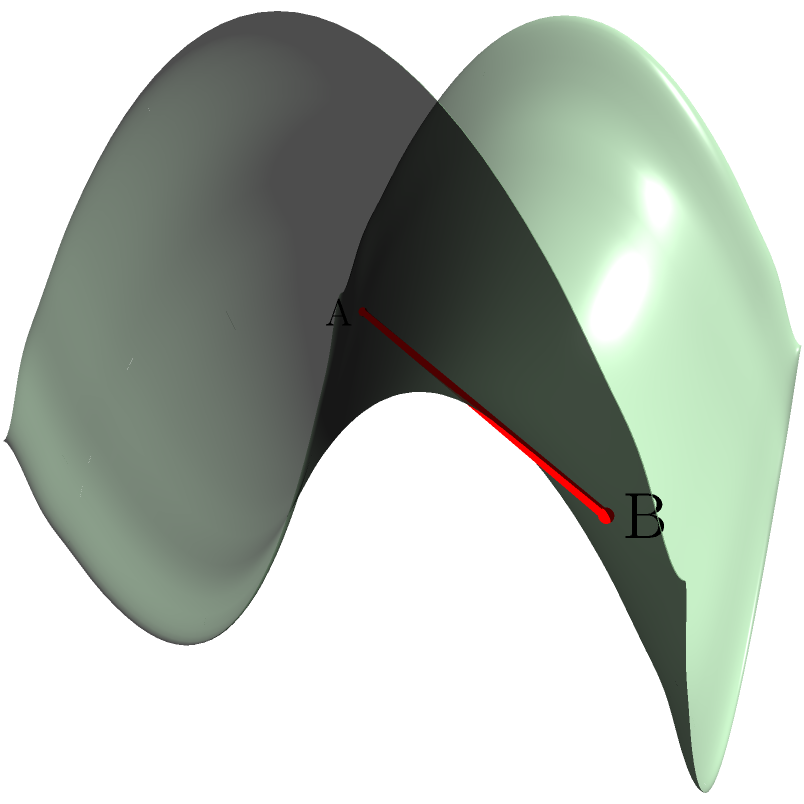On a saddle-shaped surface representing a curved keyboard, points A and B represent two notes that need to be played in rapid succession. Which path would your fingers take to minimize movement between these points? Explain your reasoning using principles of Non-Euclidean Geometry. To understand the shortest path between two points on a saddle-shaped surface, we need to consider the principles of Non-Euclidean Geometry:

1. On a curved surface, the shortest path between two points is called a geodesic.

2. In this case, the surface is a hyperbolic paraboloid, described by the equation $z = 0.5(x^2 - y^2)$.

3. Unlike on a flat surface where the shortest path is a straight line, on a saddle surface, the geodesic can appear curved when viewed from above.

4. The geodesic on this surface follows the principle of minimizing the distance while adhering to the curvature of the surface.

5. In the context of piano playing, this path represents the most efficient movement of fingers across the curved keyboard.

6. The red line in the diagram represents the geodesic between points A and B.

7. Notice that this path is not a straight line when projected onto the xy-plane, but rather follows the curvature of the surface.

8. This curved path allows the fingers to maintain contact with the keyboard surface, minimizing unnecessary vertical movement.

9. In practice, pianists intuitively learn to follow such paths to optimize their finger movements, especially on uniquely shaped keyboards or when playing complex pieces that require rapid note transitions.

Understanding this concept can help pianists visualize and optimize their finger movements, particularly when transitioning between notes that are far apart on a curved keyboard surface.
Answer: The geodesic (curved path following the surface's shape) 